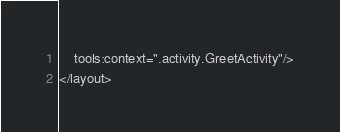Convert code to text. <code><loc_0><loc_0><loc_500><loc_500><_XML_>    tools:context=".activity.GreetActivity"/>
</layout>
</code> 